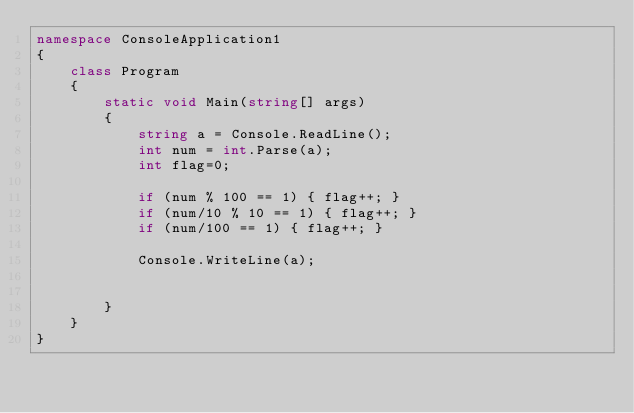Convert code to text. <code><loc_0><loc_0><loc_500><loc_500><_C#_>namespace ConsoleApplication1
{
    class Program
    {
        static void Main(string[] args)
        {
            string a = Console.ReadLine();
            int num = int.Parse(a);
            int flag=0;

            if (num % 100 == 1) { flag++; }
            if (num/10 % 10 == 1) { flag++; }
            if (num/100 == 1) { flag++; }

            Console.WriteLine(a);


        }
    }
}
</code> 